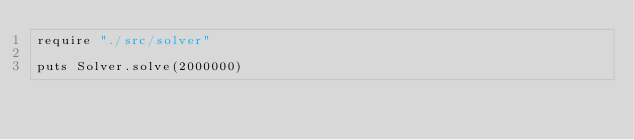Convert code to text. <code><loc_0><loc_0><loc_500><loc_500><_Crystal_>require "./src/solver"

puts Solver.solve(2000000)
</code> 